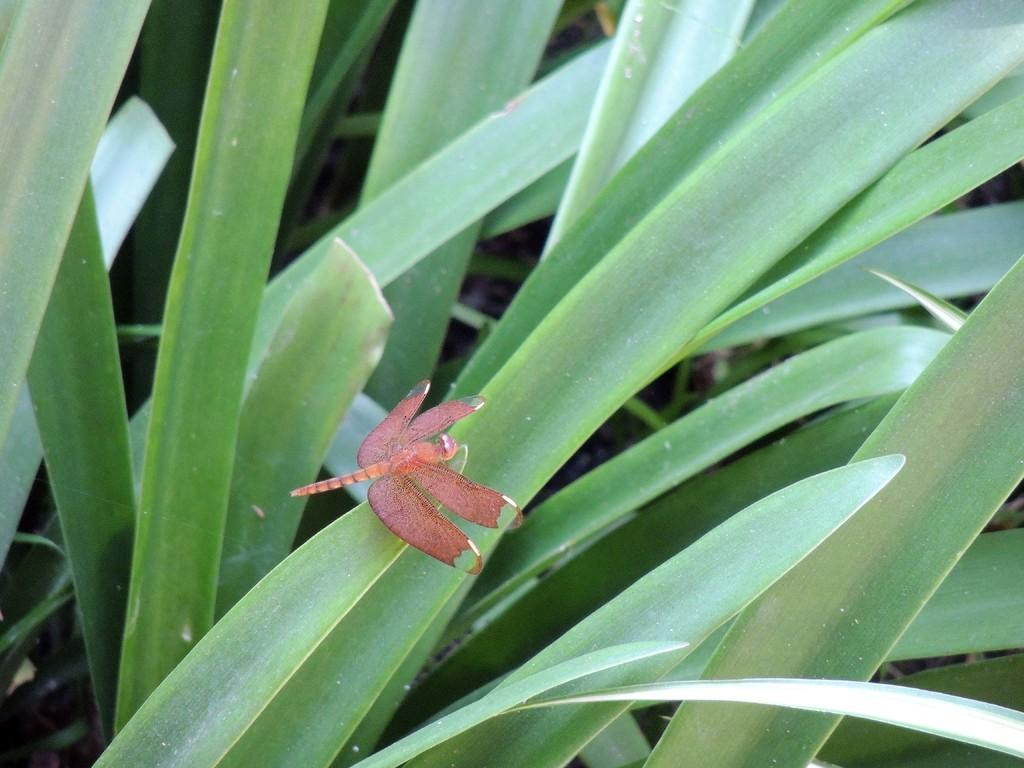What insect is present in the image? There is a dragonfly in the image. Where is the dragonfly located? The dragonfly is on a leaf. What color are the leaves visible in the image? The leaves are green. What type of silk is being used to make the baseball in the image? There is no baseball or silk present in the image; it features a dragonfly on a leaf. 